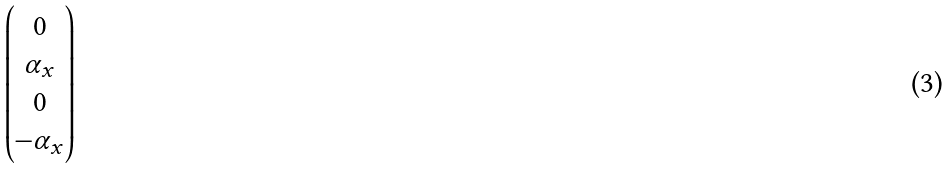<formula> <loc_0><loc_0><loc_500><loc_500>\begin{pmatrix} 0 \\ \alpha _ { x } \\ 0 \\ - \alpha _ { x } \end{pmatrix}</formula> 